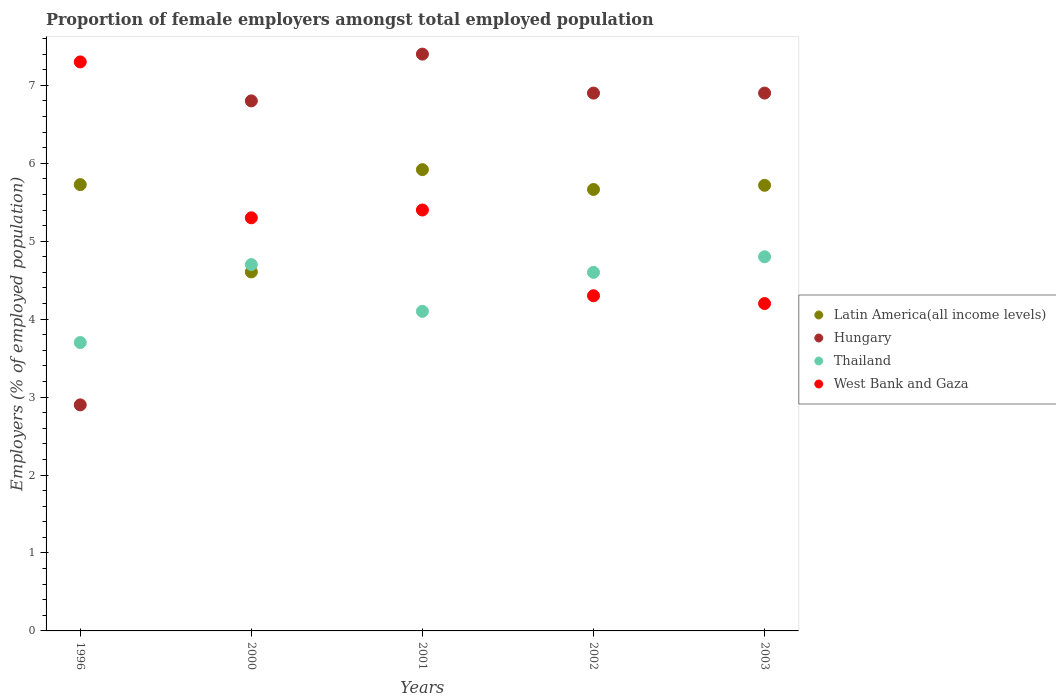How many different coloured dotlines are there?
Give a very brief answer. 4. What is the proportion of female employers in Thailand in 2003?
Your response must be concise. 4.8. Across all years, what is the maximum proportion of female employers in Thailand?
Your answer should be very brief. 4.8. Across all years, what is the minimum proportion of female employers in Hungary?
Your response must be concise. 2.9. In which year was the proportion of female employers in Thailand minimum?
Your response must be concise. 1996. What is the total proportion of female employers in Thailand in the graph?
Your response must be concise. 21.9. What is the difference between the proportion of female employers in West Bank and Gaza in 2000 and that in 2001?
Keep it short and to the point. -0.1. What is the difference between the proportion of female employers in Latin America(all income levels) in 2003 and the proportion of female employers in Hungary in 1996?
Offer a terse response. 2.82. What is the average proportion of female employers in Thailand per year?
Your response must be concise. 4.38. In the year 1996, what is the difference between the proportion of female employers in Thailand and proportion of female employers in West Bank and Gaza?
Provide a succinct answer. -3.6. What is the ratio of the proportion of female employers in Hungary in 2001 to that in 2002?
Provide a succinct answer. 1.07. Is the proportion of female employers in Thailand in 2001 less than that in 2003?
Provide a short and direct response. Yes. What is the difference between the highest and the second highest proportion of female employers in West Bank and Gaza?
Provide a succinct answer. 1.9. What is the difference between the highest and the lowest proportion of female employers in Latin America(all income levels)?
Make the answer very short. 1.31. In how many years, is the proportion of female employers in Hungary greater than the average proportion of female employers in Hungary taken over all years?
Offer a terse response. 4. Is the sum of the proportion of female employers in Thailand in 1996 and 2000 greater than the maximum proportion of female employers in Hungary across all years?
Provide a short and direct response. Yes. Is it the case that in every year, the sum of the proportion of female employers in Hungary and proportion of female employers in West Bank and Gaza  is greater than the proportion of female employers in Thailand?
Offer a very short reply. Yes. Is the proportion of female employers in Hungary strictly less than the proportion of female employers in Thailand over the years?
Your answer should be very brief. No. How many dotlines are there?
Your answer should be very brief. 4. How many years are there in the graph?
Give a very brief answer. 5. What is the difference between two consecutive major ticks on the Y-axis?
Your answer should be very brief. 1. Does the graph contain any zero values?
Your response must be concise. No. Does the graph contain grids?
Your answer should be compact. No. What is the title of the graph?
Ensure brevity in your answer.  Proportion of female employers amongst total employed population. What is the label or title of the X-axis?
Provide a succinct answer. Years. What is the label or title of the Y-axis?
Give a very brief answer. Employers (% of employed population). What is the Employers (% of employed population) in Latin America(all income levels) in 1996?
Keep it short and to the point. 5.73. What is the Employers (% of employed population) in Hungary in 1996?
Your answer should be compact. 2.9. What is the Employers (% of employed population) in Thailand in 1996?
Give a very brief answer. 3.7. What is the Employers (% of employed population) of West Bank and Gaza in 1996?
Keep it short and to the point. 7.3. What is the Employers (% of employed population) of Latin America(all income levels) in 2000?
Make the answer very short. 4.61. What is the Employers (% of employed population) of Hungary in 2000?
Make the answer very short. 6.8. What is the Employers (% of employed population) of Thailand in 2000?
Your response must be concise. 4.7. What is the Employers (% of employed population) of West Bank and Gaza in 2000?
Offer a terse response. 5.3. What is the Employers (% of employed population) in Latin America(all income levels) in 2001?
Ensure brevity in your answer.  5.92. What is the Employers (% of employed population) of Hungary in 2001?
Keep it short and to the point. 7.4. What is the Employers (% of employed population) in Thailand in 2001?
Provide a short and direct response. 4.1. What is the Employers (% of employed population) in West Bank and Gaza in 2001?
Keep it short and to the point. 5.4. What is the Employers (% of employed population) in Latin America(all income levels) in 2002?
Your answer should be compact. 5.66. What is the Employers (% of employed population) in Hungary in 2002?
Ensure brevity in your answer.  6.9. What is the Employers (% of employed population) in Thailand in 2002?
Provide a short and direct response. 4.6. What is the Employers (% of employed population) of West Bank and Gaza in 2002?
Keep it short and to the point. 4.3. What is the Employers (% of employed population) in Latin America(all income levels) in 2003?
Offer a terse response. 5.72. What is the Employers (% of employed population) in Hungary in 2003?
Provide a succinct answer. 6.9. What is the Employers (% of employed population) of Thailand in 2003?
Your answer should be very brief. 4.8. What is the Employers (% of employed population) of West Bank and Gaza in 2003?
Keep it short and to the point. 4.2. Across all years, what is the maximum Employers (% of employed population) in Latin America(all income levels)?
Offer a terse response. 5.92. Across all years, what is the maximum Employers (% of employed population) in Hungary?
Keep it short and to the point. 7.4. Across all years, what is the maximum Employers (% of employed population) in Thailand?
Offer a terse response. 4.8. Across all years, what is the maximum Employers (% of employed population) in West Bank and Gaza?
Your response must be concise. 7.3. Across all years, what is the minimum Employers (% of employed population) in Latin America(all income levels)?
Your answer should be compact. 4.61. Across all years, what is the minimum Employers (% of employed population) of Hungary?
Ensure brevity in your answer.  2.9. Across all years, what is the minimum Employers (% of employed population) in Thailand?
Provide a succinct answer. 3.7. Across all years, what is the minimum Employers (% of employed population) of West Bank and Gaza?
Keep it short and to the point. 4.2. What is the total Employers (% of employed population) of Latin America(all income levels) in the graph?
Offer a terse response. 27.63. What is the total Employers (% of employed population) in Hungary in the graph?
Offer a very short reply. 30.9. What is the total Employers (% of employed population) in Thailand in the graph?
Provide a succinct answer. 21.9. What is the difference between the Employers (% of employed population) in Latin America(all income levels) in 1996 and that in 2000?
Offer a terse response. 1.12. What is the difference between the Employers (% of employed population) in West Bank and Gaza in 1996 and that in 2000?
Keep it short and to the point. 2. What is the difference between the Employers (% of employed population) of Latin America(all income levels) in 1996 and that in 2001?
Provide a succinct answer. -0.19. What is the difference between the Employers (% of employed population) of Hungary in 1996 and that in 2001?
Your response must be concise. -4.5. What is the difference between the Employers (% of employed population) in West Bank and Gaza in 1996 and that in 2001?
Your answer should be compact. 1.9. What is the difference between the Employers (% of employed population) in Latin America(all income levels) in 1996 and that in 2002?
Provide a succinct answer. 0.06. What is the difference between the Employers (% of employed population) of Thailand in 1996 and that in 2002?
Make the answer very short. -0.9. What is the difference between the Employers (% of employed population) of West Bank and Gaza in 1996 and that in 2002?
Ensure brevity in your answer.  3. What is the difference between the Employers (% of employed population) in Latin America(all income levels) in 1996 and that in 2003?
Offer a very short reply. 0.01. What is the difference between the Employers (% of employed population) in Thailand in 1996 and that in 2003?
Offer a terse response. -1.1. What is the difference between the Employers (% of employed population) in West Bank and Gaza in 1996 and that in 2003?
Provide a succinct answer. 3.1. What is the difference between the Employers (% of employed population) in Latin America(all income levels) in 2000 and that in 2001?
Offer a very short reply. -1.31. What is the difference between the Employers (% of employed population) of Hungary in 2000 and that in 2001?
Ensure brevity in your answer.  -0.6. What is the difference between the Employers (% of employed population) of Thailand in 2000 and that in 2001?
Keep it short and to the point. 0.6. What is the difference between the Employers (% of employed population) of Latin America(all income levels) in 2000 and that in 2002?
Your answer should be compact. -1.06. What is the difference between the Employers (% of employed population) of West Bank and Gaza in 2000 and that in 2002?
Keep it short and to the point. 1. What is the difference between the Employers (% of employed population) in Latin America(all income levels) in 2000 and that in 2003?
Provide a succinct answer. -1.11. What is the difference between the Employers (% of employed population) in Hungary in 2000 and that in 2003?
Provide a succinct answer. -0.1. What is the difference between the Employers (% of employed population) in Latin America(all income levels) in 2001 and that in 2002?
Make the answer very short. 0.25. What is the difference between the Employers (% of employed population) in Hungary in 2001 and that in 2002?
Offer a very short reply. 0.5. What is the difference between the Employers (% of employed population) in Thailand in 2001 and that in 2002?
Your answer should be compact. -0.5. What is the difference between the Employers (% of employed population) of Latin America(all income levels) in 2001 and that in 2003?
Offer a terse response. 0.2. What is the difference between the Employers (% of employed population) of Thailand in 2001 and that in 2003?
Offer a very short reply. -0.7. What is the difference between the Employers (% of employed population) in West Bank and Gaza in 2001 and that in 2003?
Provide a short and direct response. 1.2. What is the difference between the Employers (% of employed population) of Latin America(all income levels) in 2002 and that in 2003?
Your answer should be very brief. -0.05. What is the difference between the Employers (% of employed population) of Hungary in 2002 and that in 2003?
Ensure brevity in your answer.  0. What is the difference between the Employers (% of employed population) of West Bank and Gaza in 2002 and that in 2003?
Provide a short and direct response. 0.1. What is the difference between the Employers (% of employed population) of Latin America(all income levels) in 1996 and the Employers (% of employed population) of Hungary in 2000?
Provide a succinct answer. -1.07. What is the difference between the Employers (% of employed population) of Latin America(all income levels) in 1996 and the Employers (% of employed population) of Thailand in 2000?
Make the answer very short. 1.03. What is the difference between the Employers (% of employed population) of Latin America(all income levels) in 1996 and the Employers (% of employed population) of West Bank and Gaza in 2000?
Make the answer very short. 0.43. What is the difference between the Employers (% of employed population) of Hungary in 1996 and the Employers (% of employed population) of Thailand in 2000?
Give a very brief answer. -1.8. What is the difference between the Employers (% of employed population) in Hungary in 1996 and the Employers (% of employed population) in West Bank and Gaza in 2000?
Keep it short and to the point. -2.4. What is the difference between the Employers (% of employed population) of Thailand in 1996 and the Employers (% of employed population) of West Bank and Gaza in 2000?
Provide a succinct answer. -1.6. What is the difference between the Employers (% of employed population) in Latin America(all income levels) in 1996 and the Employers (% of employed population) in Hungary in 2001?
Your response must be concise. -1.67. What is the difference between the Employers (% of employed population) of Latin America(all income levels) in 1996 and the Employers (% of employed population) of Thailand in 2001?
Your answer should be compact. 1.63. What is the difference between the Employers (% of employed population) in Latin America(all income levels) in 1996 and the Employers (% of employed population) in West Bank and Gaza in 2001?
Offer a terse response. 0.33. What is the difference between the Employers (% of employed population) of Thailand in 1996 and the Employers (% of employed population) of West Bank and Gaza in 2001?
Give a very brief answer. -1.7. What is the difference between the Employers (% of employed population) of Latin America(all income levels) in 1996 and the Employers (% of employed population) of Hungary in 2002?
Your response must be concise. -1.17. What is the difference between the Employers (% of employed population) in Latin America(all income levels) in 1996 and the Employers (% of employed population) in Thailand in 2002?
Provide a short and direct response. 1.13. What is the difference between the Employers (% of employed population) of Latin America(all income levels) in 1996 and the Employers (% of employed population) of West Bank and Gaza in 2002?
Offer a terse response. 1.43. What is the difference between the Employers (% of employed population) in Hungary in 1996 and the Employers (% of employed population) in Thailand in 2002?
Make the answer very short. -1.7. What is the difference between the Employers (% of employed population) in Hungary in 1996 and the Employers (% of employed population) in West Bank and Gaza in 2002?
Ensure brevity in your answer.  -1.4. What is the difference between the Employers (% of employed population) in Thailand in 1996 and the Employers (% of employed population) in West Bank and Gaza in 2002?
Keep it short and to the point. -0.6. What is the difference between the Employers (% of employed population) in Latin America(all income levels) in 1996 and the Employers (% of employed population) in Hungary in 2003?
Make the answer very short. -1.17. What is the difference between the Employers (% of employed population) in Latin America(all income levels) in 1996 and the Employers (% of employed population) in Thailand in 2003?
Offer a terse response. 0.93. What is the difference between the Employers (% of employed population) of Latin America(all income levels) in 1996 and the Employers (% of employed population) of West Bank and Gaza in 2003?
Offer a terse response. 1.53. What is the difference between the Employers (% of employed population) of Thailand in 1996 and the Employers (% of employed population) of West Bank and Gaza in 2003?
Your answer should be very brief. -0.5. What is the difference between the Employers (% of employed population) of Latin America(all income levels) in 2000 and the Employers (% of employed population) of Hungary in 2001?
Your answer should be compact. -2.79. What is the difference between the Employers (% of employed population) in Latin America(all income levels) in 2000 and the Employers (% of employed population) in Thailand in 2001?
Keep it short and to the point. 0.51. What is the difference between the Employers (% of employed population) in Latin America(all income levels) in 2000 and the Employers (% of employed population) in West Bank and Gaza in 2001?
Ensure brevity in your answer.  -0.79. What is the difference between the Employers (% of employed population) of Hungary in 2000 and the Employers (% of employed population) of Thailand in 2001?
Offer a terse response. 2.7. What is the difference between the Employers (% of employed population) in Thailand in 2000 and the Employers (% of employed population) in West Bank and Gaza in 2001?
Provide a short and direct response. -0.7. What is the difference between the Employers (% of employed population) in Latin America(all income levels) in 2000 and the Employers (% of employed population) in Hungary in 2002?
Offer a very short reply. -2.29. What is the difference between the Employers (% of employed population) of Latin America(all income levels) in 2000 and the Employers (% of employed population) of Thailand in 2002?
Make the answer very short. 0.01. What is the difference between the Employers (% of employed population) of Latin America(all income levels) in 2000 and the Employers (% of employed population) of West Bank and Gaza in 2002?
Provide a short and direct response. 0.31. What is the difference between the Employers (% of employed population) of Hungary in 2000 and the Employers (% of employed population) of Thailand in 2002?
Provide a short and direct response. 2.2. What is the difference between the Employers (% of employed population) in Thailand in 2000 and the Employers (% of employed population) in West Bank and Gaza in 2002?
Give a very brief answer. 0.4. What is the difference between the Employers (% of employed population) of Latin America(all income levels) in 2000 and the Employers (% of employed population) of Hungary in 2003?
Provide a succinct answer. -2.29. What is the difference between the Employers (% of employed population) of Latin America(all income levels) in 2000 and the Employers (% of employed population) of Thailand in 2003?
Your response must be concise. -0.19. What is the difference between the Employers (% of employed population) in Latin America(all income levels) in 2000 and the Employers (% of employed population) in West Bank and Gaza in 2003?
Your answer should be compact. 0.41. What is the difference between the Employers (% of employed population) of Hungary in 2000 and the Employers (% of employed population) of Thailand in 2003?
Your answer should be compact. 2. What is the difference between the Employers (% of employed population) of Latin America(all income levels) in 2001 and the Employers (% of employed population) of Hungary in 2002?
Your answer should be very brief. -0.98. What is the difference between the Employers (% of employed population) of Latin America(all income levels) in 2001 and the Employers (% of employed population) of Thailand in 2002?
Provide a short and direct response. 1.32. What is the difference between the Employers (% of employed population) of Latin America(all income levels) in 2001 and the Employers (% of employed population) of West Bank and Gaza in 2002?
Offer a terse response. 1.62. What is the difference between the Employers (% of employed population) in Hungary in 2001 and the Employers (% of employed population) in West Bank and Gaza in 2002?
Give a very brief answer. 3.1. What is the difference between the Employers (% of employed population) of Latin America(all income levels) in 2001 and the Employers (% of employed population) of Hungary in 2003?
Ensure brevity in your answer.  -0.98. What is the difference between the Employers (% of employed population) of Latin America(all income levels) in 2001 and the Employers (% of employed population) of Thailand in 2003?
Offer a very short reply. 1.12. What is the difference between the Employers (% of employed population) of Latin America(all income levels) in 2001 and the Employers (% of employed population) of West Bank and Gaza in 2003?
Offer a very short reply. 1.72. What is the difference between the Employers (% of employed population) of Hungary in 2001 and the Employers (% of employed population) of Thailand in 2003?
Keep it short and to the point. 2.6. What is the difference between the Employers (% of employed population) in Latin America(all income levels) in 2002 and the Employers (% of employed population) in Hungary in 2003?
Make the answer very short. -1.24. What is the difference between the Employers (% of employed population) in Latin America(all income levels) in 2002 and the Employers (% of employed population) in Thailand in 2003?
Provide a short and direct response. 0.86. What is the difference between the Employers (% of employed population) in Latin America(all income levels) in 2002 and the Employers (% of employed population) in West Bank and Gaza in 2003?
Your response must be concise. 1.46. What is the difference between the Employers (% of employed population) of Hungary in 2002 and the Employers (% of employed population) of West Bank and Gaza in 2003?
Keep it short and to the point. 2.7. What is the average Employers (% of employed population) in Latin America(all income levels) per year?
Keep it short and to the point. 5.53. What is the average Employers (% of employed population) in Hungary per year?
Your answer should be very brief. 6.18. What is the average Employers (% of employed population) of Thailand per year?
Your answer should be compact. 4.38. In the year 1996, what is the difference between the Employers (% of employed population) of Latin America(all income levels) and Employers (% of employed population) of Hungary?
Offer a terse response. 2.83. In the year 1996, what is the difference between the Employers (% of employed population) of Latin America(all income levels) and Employers (% of employed population) of Thailand?
Your response must be concise. 2.03. In the year 1996, what is the difference between the Employers (% of employed population) in Latin America(all income levels) and Employers (% of employed population) in West Bank and Gaza?
Your answer should be very brief. -1.57. In the year 1996, what is the difference between the Employers (% of employed population) in Hungary and Employers (% of employed population) in West Bank and Gaza?
Keep it short and to the point. -4.4. In the year 1996, what is the difference between the Employers (% of employed population) of Thailand and Employers (% of employed population) of West Bank and Gaza?
Offer a very short reply. -3.6. In the year 2000, what is the difference between the Employers (% of employed population) in Latin America(all income levels) and Employers (% of employed population) in Hungary?
Your answer should be very brief. -2.19. In the year 2000, what is the difference between the Employers (% of employed population) of Latin America(all income levels) and Employers (% of employed population) of Thailand?
Your answer should be very brief. -0.09. In the year 2000, what is the difference between the Employers (% of employed population) of Latin America(all income levels) and Employers (% of employed population) of West Bank and Gaza?
Provide a succinct answer. -0.69. In the year 2000, what is the difference between the Employers (% of employed population) in Thailand and Employers (% of employed population) in West Bank and Gaza?
Provide a succinct answer. -0.6. In the year 2001, what is the difference between the Employers (% of employed population) of Latin America(all income levels) and Employers (% of employed population) of Hungary?
Your answer should be compact. -1.48. In the year 2001, what is the difference between the Employers (% of employed population) in Latin America(all income levels) and Employers (% of employed population) in Thailand?
Your answer should be compact. 1.82. In the year 2001, what is the difference between the Employers (% of employed population) in Latin America(all income levels) and Employers (% of employed population) in West Bank and Gaza?
Offer a very short reply. 0.52. In the year 2001, what is the difference between the Employers (% of employed population) of Hungary and Employers (% of employed population) of Thailand?
Your response must be concise. 3.3. In the year 2001, what is the difference between the Employers (% of employed population) of Hungary and Employers (% of employed population) of West Bank and Gaza?
Your answer should be compact. 2. In the year 2002, what is the difference between the Employers (% of employed population) of Latin America(all income levels) and Employers (% of employed population) of Hungary?
Offer a terse response. -1.24. In the year 2002, what is the difference between the Employers (% of employed population) in Latin America(all income levels) and Employers (% of employed population) in Thailand?
Your response must be concise. 1.06. In the year 2002, what is the difference between the Employers (% of employed population) of Latin America(all income levels) and Employers (% of employed population) of West Bank and Gaza?
Your answer should be compact. 1.36. In the year 2002, what is the difference between the Employers (% of employed population) of Hungary and Employers (% of employed population) of Thailand?
Offer a very short reply. 2.3. In the year 2003, what is the difference between the Employers (% of employed population) in Latin America(all income levels) and Employers (% of employed population) in Hungary?
Make the answer very short. -1.18. In the year 2003, what is the difference between the Employers (% of employed population) in Latin America(all income levels) and Employers (% of employed population) in Thailand?
Offer a very short reply. 0.92. In the year 2003, what is the difference between the Employers (% of employed population) in Latin America(all income levels) and Employers (% of employed population) in West Bank and Gaza?
Provide a succinct answer. 1.52. In the year 2003, what is the difference between the Employers (% of employed population) of Hungary and Employers (% of employed population) of Thailand?
Your answer should be very brief. 2.1. In the year 2003, what is the difference between the Employers (% of employed population) of Hungary and Employers (% of employed population) of West Bank and Gaza?
Give a very brief answer. 2.7. In the year 2003, what is the difference between the Employers (% of employed population) in Thailand and Employers (% of employed population) in West Bank and Gaza?
Your answer should be very brief. 0.6. What is the ratio of the Employers (% of employed population) of Latin America(all income levels) in 1996 to that in 2000?
Your response must be concise. 1.24. What is the ratio of the Employers (% of employed population) in Hungary in 1996 to that in 2000?
Make the answer very short. 0.43. What is the ratio of the Employers (% of employed population) in Thailand in 1996 to that in 2000?
Make the answer very short. 0.79. What is the ratio of the Employers (% of employed population) in West Bank and Gaza in 1996 to that in 2000?
Offer a very short reply. 1.38. What is the ratio of the Employers (% of employed population) in Latin America(all income levels) in 1996 to that in 2001?
Your answer should be very brief. 0.97. What is the ratio of the Employers (% of employed population) of Hungary in 1996 to that in 2001?
Give a very brief answer. 0.39. What is the ratio of the Employers (% of employed population) in Thailand in 1996 to that in 2001?
Your response must be concise. 0.9. What is the ratio of the Employers (% of employed population) in West Bank and Gaza in 1996 to that in 2001?
Make the answer very short. 1.35. What is the ratio of the Employers (% of employed population) of Latin America(all income levels) in 1996 to that in 2002?
Your answer should be compact. 1.01. What is the ratio of the Employers (% of employed population) of Hungary in 1996 to that in 2002?
Give a very brief answer. 0.42. What is the ratio of the Employers (% of employed population) of Thailand in 1996 to that in 2002?
Offer a terse response. 0.8. What is the ratio of the Employers (% of employed population) in West Bank and Gaza in 1996 to that in 2002?
Give a very brief answer. 1.7. What is the ratio of the Employers (% of employed population) in Latin America(all income levels) in 1996 to that in 2003?
Offer a very short reply. 1. What is the ratio of the Employers (% of employed population) of Hungary in 1996 to that in 2003?
Give a very brief answer. 0.42. What is the ratio of the Employers (% of employed population) in Thailand in 1996 to that in 2003?
Ensure brevity in your answer.  0.77. What is the ratio of the Employers (% of employed population) in West Bank and Gaza in 1996 to that in 2003?
Ensure brevity in your answer.  1.74. What is the ratio of the Employers (% of employed population) in Latin America(all income levels) in 2000 to that in 2001?
Keep it short and to the point. 0.78. What is the ratio of the Employers (% of employed population) of Hungary in 2000 to that in 2001?
Make the answer very short. 0.92. What is the ratio of the Employers (% of employed population) of Thailand in 2000 to that in 2001?
Provide a succinct answer. 1.15. What is the ratio of the Employers (% of employed population) in West Bank and Gaza in 2000 to that in 2001?
Offer a very short reply. 0.98. What is the ratio of the Employers (% of employed population) in Latin America(all income levels) in 2000 to that in 2002?
Make the answer very short. 0.81. What is the ratio of the Employers (% of employed population) in Hungary in 2000 to that in 2002?
Ensure brevity in your answer.  0.99. What is the ratio of the Employers (% of employed population) of Thailand in 2000 to that in 2002?
Offer a very short reply. 1.02. What is the ratio of the Employers (% of employed population) of West Bank and Gaza in 2000 to that in 2002?
Provide a short and direct response. 1.23. What is the ratio of the Employers (% of employed population) in Latin America(all income levels) in 2000 to that in 2003?
Provide a short and direct response. 0.81. What is the ratio of the Employers (% of employed population) in Hungary in 2000 to that in 2003?
Make the answer very short. 0.99. What is the ratio of the Employers (% of employed population) of Thailand in 2000 to that in 2003?
Provide a succinct answer. 0.98. What is the ratio of the Employers (% of employed population) in West Bank and Gaza in 2000 to that in 2003?
Offer a terse response. 1.26. What is the ratio of the Employers (% of employed population) of Latin America(all income levels) in 2001 to that in 2002?
Offer a terse response. 1.04. What is the ratio of the Employers (% of employed population) in Hungary in 2001 to that in 2002?
Your answer should be compact. 1.07. What is the ratio of the Employers (% of employed population) of Thailand in 2001 to that in 2002?
Make the answer very short. 0.89. What is the ratio of the Employers (% of employed population) in West Bank and Gaza in 2001 to that in 2002?
Ensure brevity in your answer.  1.26. What is the ratio of the Employers (% of employed population) in Latin America(all income levels) in 2001 to that in 2003?
Give a very brief answer. 1.04. What is the ratio of the Employers (% of employed population) in Hungary in 2001 to that in 2003?
Keep it short and to the point. 1.07. What is the ratio of the Employers (% of employed population) of Thailand in 2001 to that in 2003?
Keep it short and to the point. 0.85. What is the ratio of the Employers (% of employed population) in Latin America(all income levels) in 2002 to that in 2003?
Your answer should be compact. 0.99. What is the ratio of the Employers (% of employed population) of West Bank and Gaza in 2002 to that in 2003?
Your answer should be compact. 1.02. What is the difference between the highest and the second highest Employers (% of employed population) of Latin America(all income levels)?
Provide a succinct answer. 0.19. What is the difference between the highest and the second highest Employers (% of employed population) of Thailand?
Your answer should be compact. 0.1. What is the difference between the highest and the second highest Employers (% of employed population) of West Bank and Gaza?
Your answer should be very brief. 1.9. What is the difference between the highest and the lowest Employers (% of employed population) in Latin America(all income levels)?
Provide a succinct answer. 1.31. What is the difference between the highest and the lowest Employers (% of employed population) in Hungary?
Provide a succinct answer. 4.5. What is the difference between the highest and the lowest Employers (% of employed population) of West Bank and Gaza?
Make the answer very short. 3.1. 